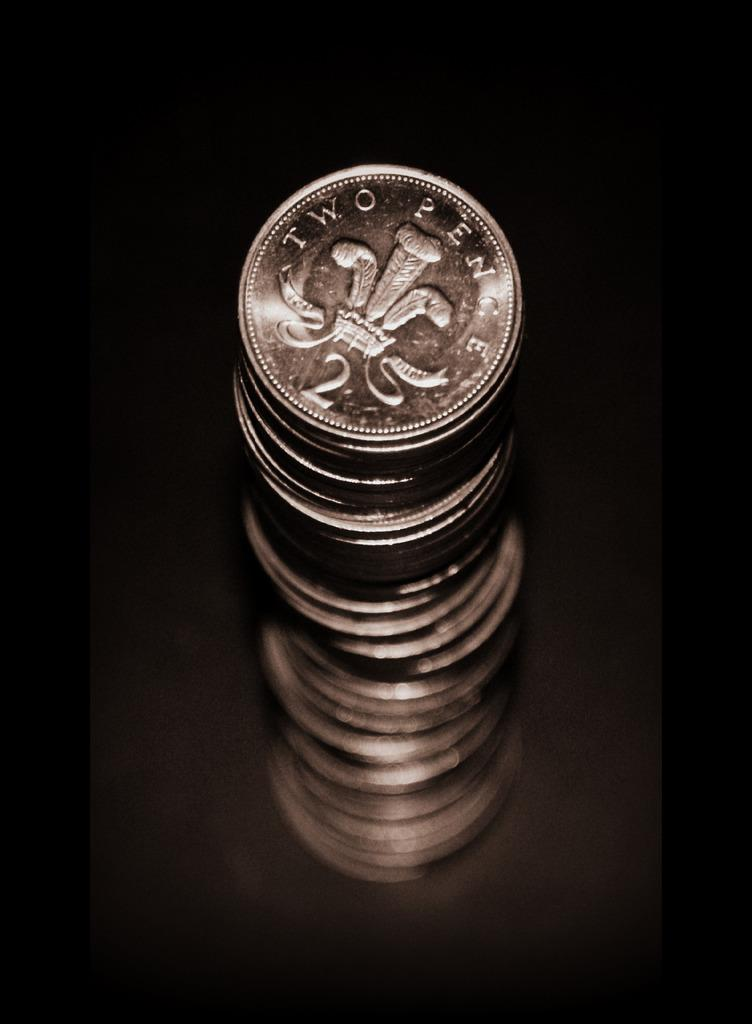<image>
Create a compact narrative representing the image presented. A tall stack of Two Pence silver coins against a black background. 